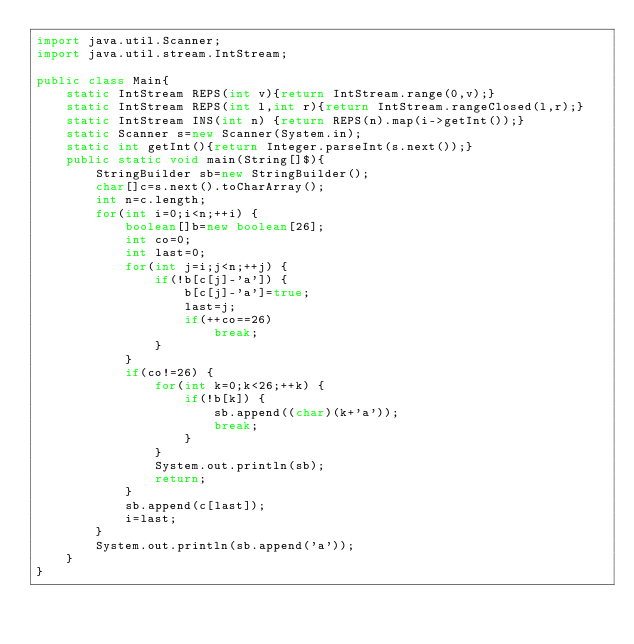<code> <loc_0><loc_0><loc_500><loc_500><_Java_>import java.util.Scanner;
import java.util.stream.IntStream;

public class Main{
	static IntStream REPS(int v){return IntStream.range(0,v);}
	static IntStream REPS(int l,int r){return IntStream.rangeClosed(l,r);}
	static IntStream INS(int n) {return REPS(n).map(i->getInt());}
	static Scanner s=new Scanner(System.in);
	static int getInt(){return Integer.parseInt(s.next());}
	public static void main(String[]$){
		StringBuilder sb=new StringBuilder();
		char[]c=s.next().toCharArray();
		int n=c.length;
		for(int i=0;i<n;++i) {
			boolean[]b=new boolean[26];
			int co=0;
			int last=0;
			for(int j=i;j<n;++j) {
				if(!b[c[j]-'a']) {
					b[c[j]-'a']=true;
					last=j;
					if(++co==26)
						break;
				}
			}
			if(co!=26) {
				for(int k=0;k<26;++k) {
					if(!b[k]) {
						sb.append((char)(k+'a'));
						break;
					}
				}
				System.out.println(sb);
				return;
			}
			sb.append(c[last]);
			i=last;
		}
		System.out.println(sb.append('a'));
	}
}</code> 